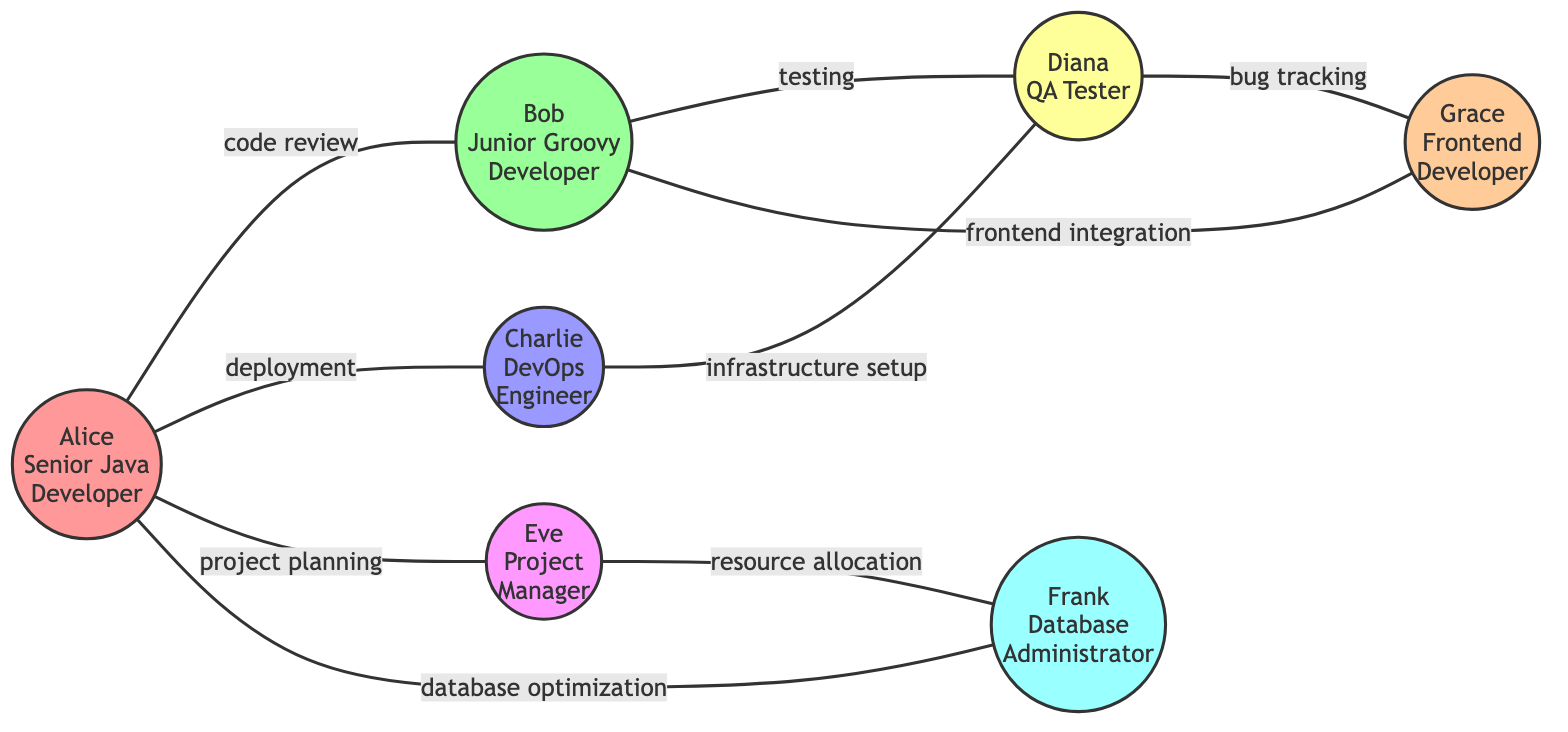What is the role of Alice? From the node representing Alice, it is stated that she is a Senior Java Developer.
Answer: Senior Java Developer How many nodes are present in the graph? The graph lists 7 distinct individuals as nodes, which can be counted in the provided data.
Answer: 7 Which two colleagues are involved in code review? The edge labeled 'code review' connects Alice and Bob, indicating they are the ones involved in this interaction.
Answer: Alice and Bob What interaction occurs between Bob and Grace? The edge labeled 'frontend integration' indicates that the interaction between Bob and Grace is specifically focused on this topic.
Answer: frontend integration Who does Eve collaborate with for resource allocation? Reviewing the edges, the connection shows that Eve collaborates with Frank for resource allocation.
Answer: Frank Which colleague interacts with both Diana and Charlie, and what is the type of interaction with each? Bob interacts with Diana in testing, and Charlie interacts with Diana in infrastructure setup, as evident from the respective edges.
Answer: testing, infrastructure setup How many total edges are represented in the graph? Counting the individual connections listed in the edges section yields a total of 8 edges.
Answer: 8 Which role has interactions with the most colleagues? Assessing the edges, Alice has connections with four colleagues, more than any other role in the graph.
Answer: Senior Java Developer Is there any direct interaction between a QA Tester and a Junior Groovy Developer in the graph? Yes, the edges indicate that Bob, the Junior Groovy Developer, collaborates with Diana, the QA Tester, indicating a direct interaction.
Answer: Yes 